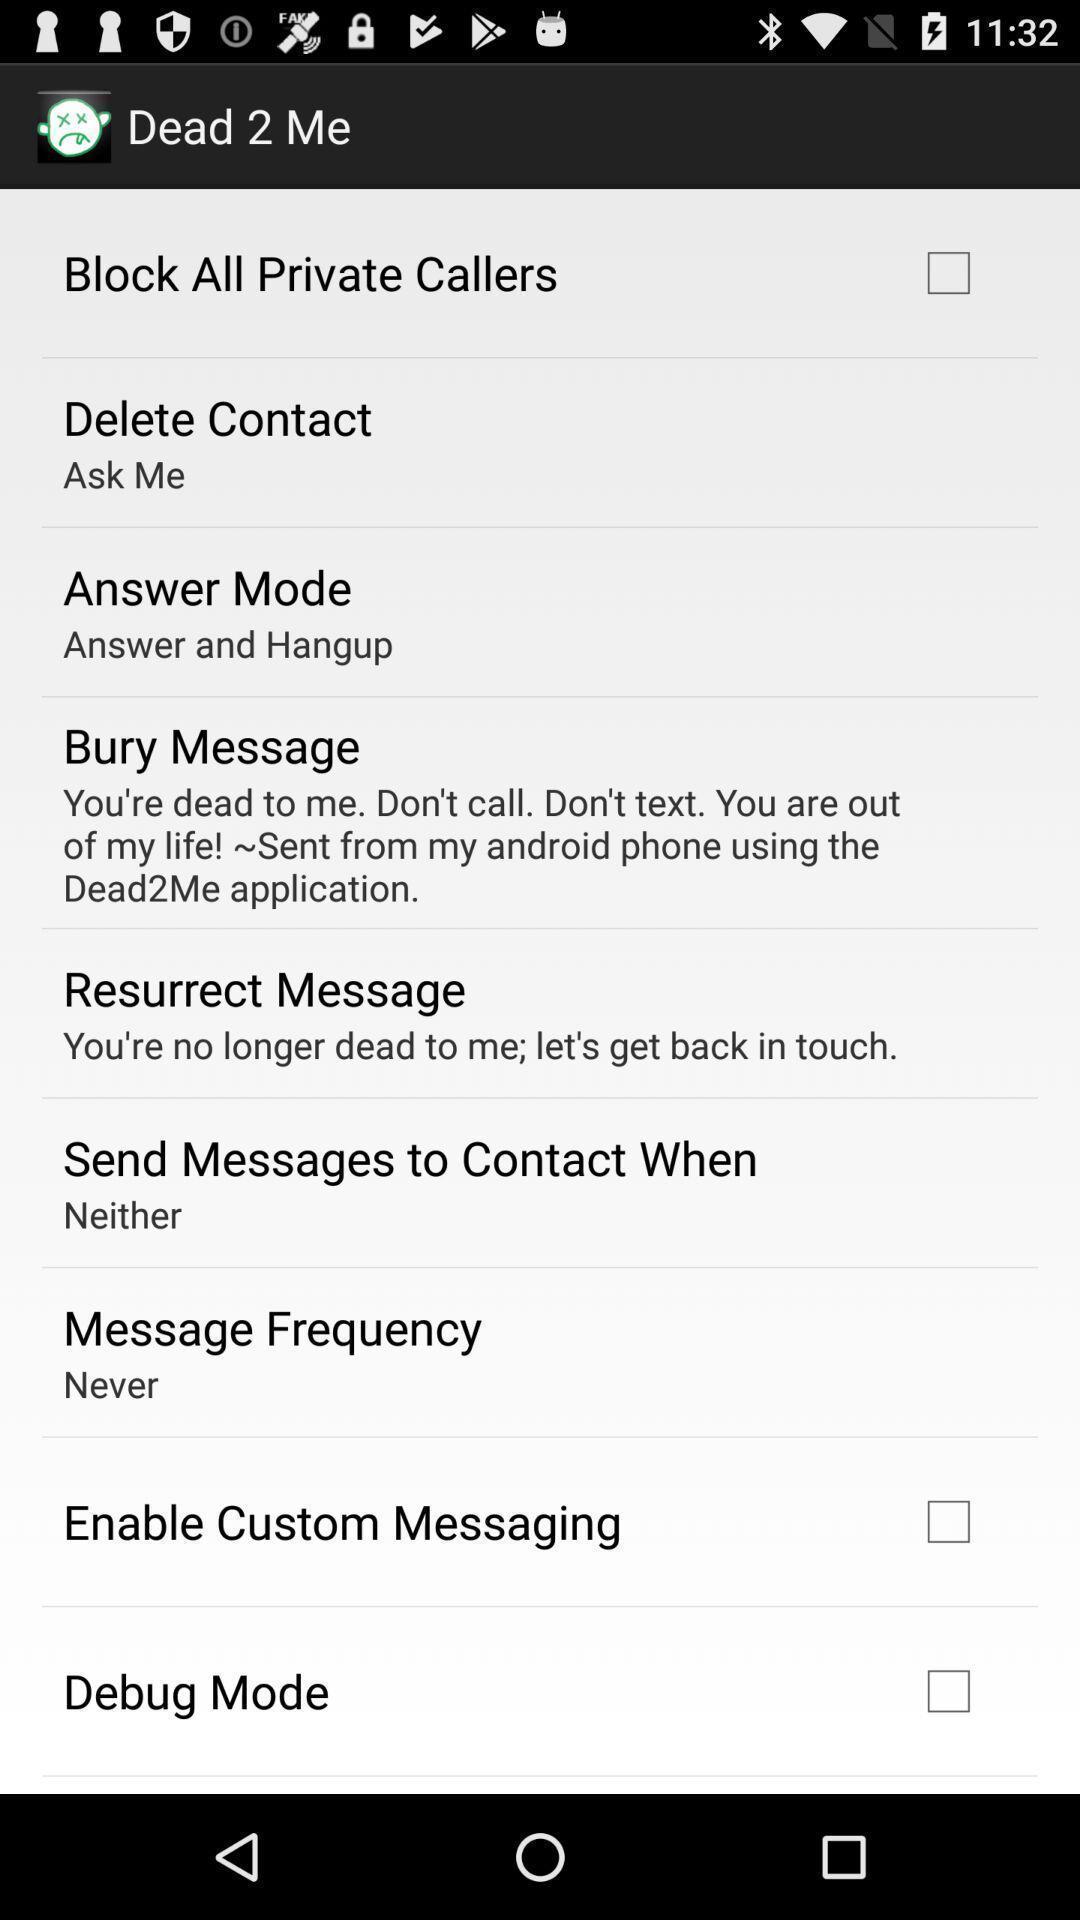Summarize the main components in this picture. Settings page for setting all calls. 